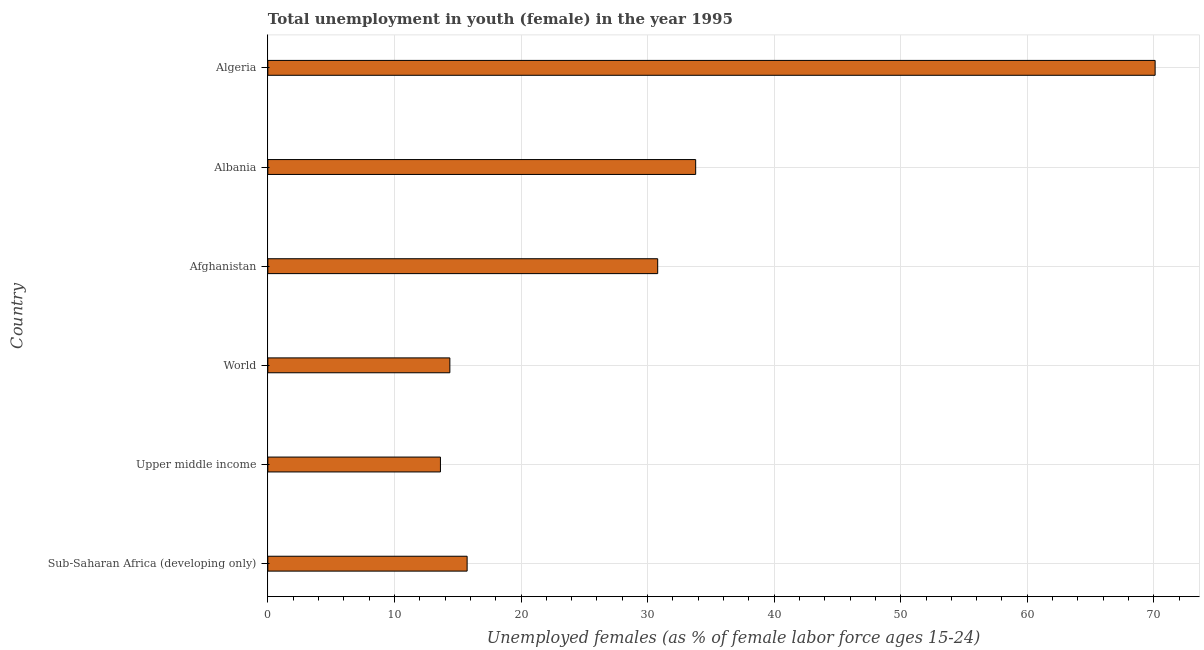Does the graph contain any zero values?
Make the answer very short. No. Does the graph contain grids?
Provide a short and direct response. Yes. What is the title of the graph?
Your response must be concise. Total unemployment in youth (female) in the year 1995. What is the label or title of the X-axis?
Give a very brief answer. Unemployed females (as % of female labor force ages 15-24). What is the label or title of the Y-axis?
Give a very brief answer. Country. What is the unemployed female youth population in Algeria?
Ensure brevity in your answer.  70.1. Across all countries, what is the maximum unemployed female youth population?
Give a very brief answer. 70.1. Across all countries, what is the minimum unemployed female youth population?
Keep it short and to the point. 13.64. In which country was the unemployed female youth population maximum?
Provide a succinct answer. Algeria. In which country was the unemployed female youth population minimum?
Your answer should be compact. Upper middle income. What is the sum of the unemployed female youth population?
Make the answer very short. 178.46. What is the difference between the unemployed female youth population in Afghanistan and World?
Give a very brief answer. 16.42. What is the average unemployed female youth population per country?
Provide a short and direct response. 29.74. What is the median unemployed female youth population?
Ensure brevity in your answer.  23.27. What is the ratio of the unemployed female youth population in Albania to that in Sub-Saharan Africa (developing only)?
Give a very brief answer. 2.15. What is the difference between the highest and the second highest unemployed female youth population?
Ensure brevity in your answer.  36.3. What is the difference between the highest and the lowest unemployed female youth population?
Your answer should be compact. 56.46. How many bars are there?
Your response must be concise. 6. Are all the bars in the graph horizontal?
Provide a succinct answer. Yes. How many countries are there in the graph?
Your answer should be compact. 6. What is the difference between two consecutive major ticks on the X-axis?
Your response must be concise. 10. Are the values on the major ticks of X-axis written in scientific E-notation?
Offer a very short reply. No. What is the Unemployed females (as % of female labor force ages 15-24) in Sub-Saharan Africa (developing only)?
Offer a very short reply. 15.74. What is the Unemployed females (as % of female labor force ages 15-24) in Upper middle income?
Your answer should be very brief. 13.64. What is the Unemployed females (as % of female labor force ages 15-24) of World?
Offer a terse response. 14.38. What is the Unemployed females (as % of female labor force ages 15-24) of Afghanistan?
Offer a very short reply. 30.8. What is the Unemployed females (as % of female labor force ages 15-24) of Albania?
Ensure brevity in your answer.  33.8. What is the Unemployed females (as % of female labor force ages 15-24) in Algeria?
Keep it short and to the point. 70.1. What is the difference between the Unemployed females (as % of female labor force ages 15-24) in Sub-Saharan Africa (developing only) and Upper middle income?
Ensure brevity in your answer.  2.11. What is the difference between the Unemployed females (as % of female labor force ages 15-24) in Sub-Saharan Africa (developing only) and World?
Provide a succinct answer. 1.36. What is the difference between the Unemployed females (as % of female labor force ages 15-24) in Sub-Saharan Africa (developing only) and Afghanistan?
Offer a very short reply. -15.06. What is the difference between the Unemployed females (as % of female labor force ages 15-24) in Sub-Saharan Africa (developing only) and Albania?
Provide a short and direct response. -18.06. What is the difference between the Unemployed females (as % of female labor force ages 15-24) in Sub-Saharan Africa (developing only) and Algeria?
Your answer should be very brief. -54.36. What is the difference between the Unemployed females (as % of female labor force ages 15-24) in Upper middle income and World?
Your answer should be compact. -0.74. What is the difference between the Unemployed females (as % of female labor force ages 15-24) in Upper middle income and Afghanistan?
Your response must be concise. -17.16. What is the difference between the Unemployed females (as % of female labor force ages 15-24) in Upper middle income and Albania?
Ensure brevity in your answer.  -20.16. What is the difference between the Unemployed females (as % of female labor force ages 15-24) in Upper middle income and Algeria?
Your answer should be compact. -56.46. What is the difference between the Unemployed females (as % of female labor force ages 15-24) in World and Afghanistan?
Your response must be concise. -16.42. What is the difference between the Unemployed females (as % of female labor force ages 15-24) in World and Albania?
Your answer should be compact. -19.42. What is the difference between the Unemployed females (as % of female labor force ages 15-24) in World and Algeria?
Your answer should be compact. -55.72. What is the difference between the Unemployed females (as % of female labor force ages 15-24) in Afghanistan and Albania?
Offer a very short reply. -3. What is the difference between the Unemployed females (as % of female labor force ages 15-24) in Afghanistan and Algeria?
Offer a terse response. -39.3. What is the difference between the Unemployed females (as % of female labor force ages 15-24) in Albania and Algeria?
Offer a very short reply. -36.3. What is the ratio of the Unemployed females (as % of female labor force ages 15-24) in Sub-Saharan Africa (developing only) to that in Upper middle income?
Make the answer very short. 1.16. What is the ratio of the Unemployed females (as % of female labor force ages 15-24) in Sub-Saharan Africa (developing only) to that in World?
Keep it short and to the point. 1.09. What is the ratio of the Unemployed females (as % of female labor force ages 15-24) in Sub-Saharan Africa (developing only) to that in Afghanistan?
Give a very brief answer. 0.51. What is the ratio of the Unemployed females (as % of female labor force ages 15-24) in Sub-Saharan Africa (developing only) to that in Albania?
Give a very brief answer. 0.47. What is the ratio of the Unemployed females (as % of female labor force ages 15-24) in Sub-Saharan Africa (developing only) to that in Algeria?
Your response must be concise. 0.23. What is the ratio of the Unemployed females (as % of female labor force ages 15-24) in Upper middle income to that in World?
Your answer should be compact. 0.95. What is the ratio of the Unemployed females (as % of female labor force ages 15-24) in Upper middle income to that in Afghanistan?
Your answer should be compact. 0.44. What is the ratio of the Unemployed females (as % of female labor force ages 15-24) in Upper middle income to that in Albania?
Ensure brevity in your answer.  0.4. What is the ratio of the Unemployed females (as % of female labor force ages 15-24) in Upper middle income to that in Algeria?
Your response must be concise. 0.2. What is the ratio of the Unemployed females (as % of female labor force ages 15-24) in World to that in Afghanistan?
Keep it short and to the point. 0.47. What is the ratio of the Unemployed females (as % of female labor force ages 15-24) in World to that in Albania?
Offer a terse response. 0.42. What is the ratio of the Unemployed females (as % of female labor force ages 15-24) in World to that in Algeria?
Offer a very short reply. 0.2. What is the ratio of the Unemployed females (as % of female labor force ages 15-24) in Afghanistan to that in Albania?
Keep it short and to the point. 0.91. What is the ratio of the Unemployed females (as % of female labor force ages 15-24) in Afghanistan to that in Algeria?
Your response must be concise. 0.44. What is the ratio of the Unemployed females (as % of female labor force ages 15-24) in Albania to that in Algeria?
Provide a short and direct response. 0.48. 